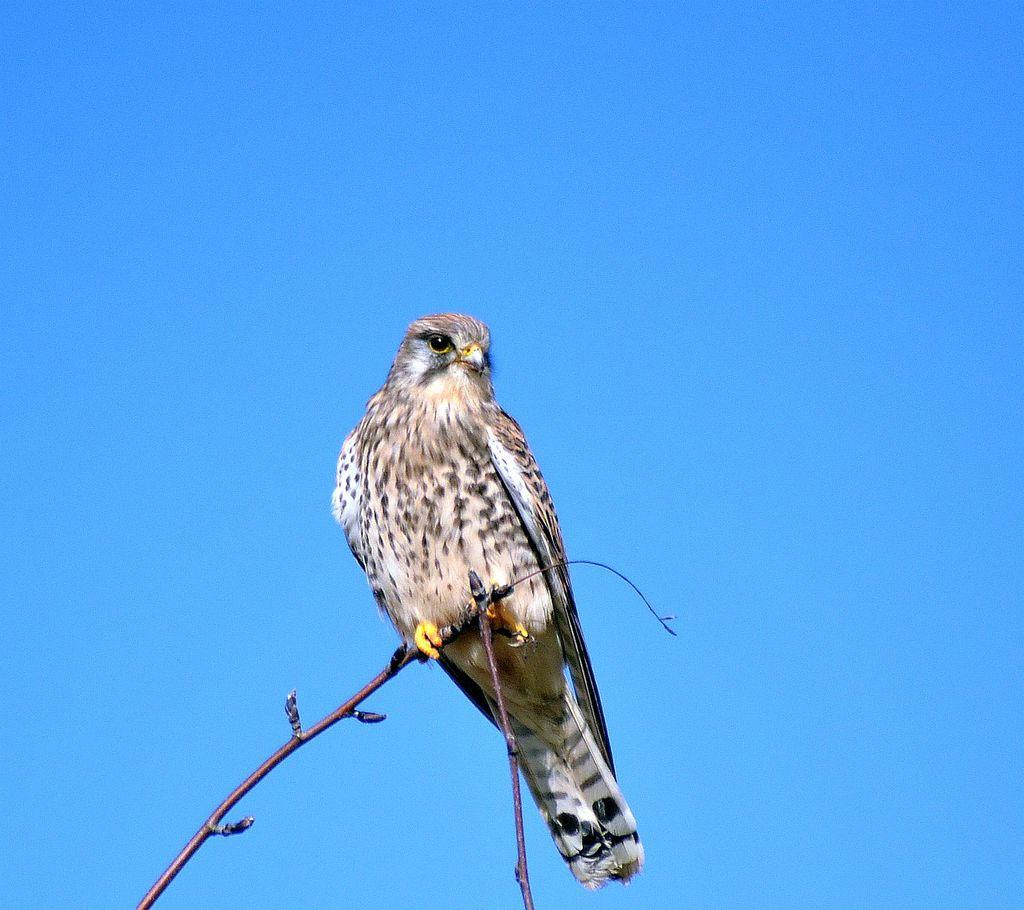What type of animal can be seen in the image? There is a bird in the image. Where is the bird located in the image? The bird is standing on a branch. What color is the background of the image? The background of the image is blue. What type of stew is being prepared in the image? There is no stew present in the image; it features a bird standing on a branch with a blue background. 